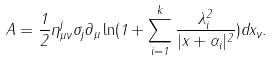Convert formula to latex. <formula><loc_0><loc_0><loc_500><loc_500>A = \frac { 1 } { 2 } \eta _ { \mu \nu } ^ { j } \sigma _ { j } \partial _ { \mu } \ln ( 1 + \sum _ { i = 1 } ^ { k } \frac { \lambda _ { i } ^ { 2 } } { | x + \alpha _ { i } | ^ { 2 } } ) d x _ { \nu } .</formula> 